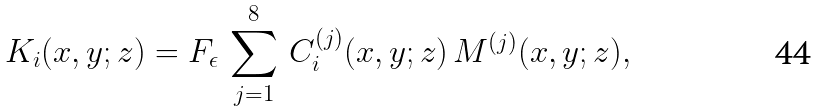Convert formula to latex. <formula><loc_0><loc_0><loc_500><loc_500>K _ { i } ( x , y ; z ) = F _ { \epsilon } \, \sum _ { j = 1 } ^ { 8 } \, C _ { i } ^ { ( j ) } ( x , y ; z ) \, M ^ { ( j ) } ( x , y ; z ) ,</formula> 